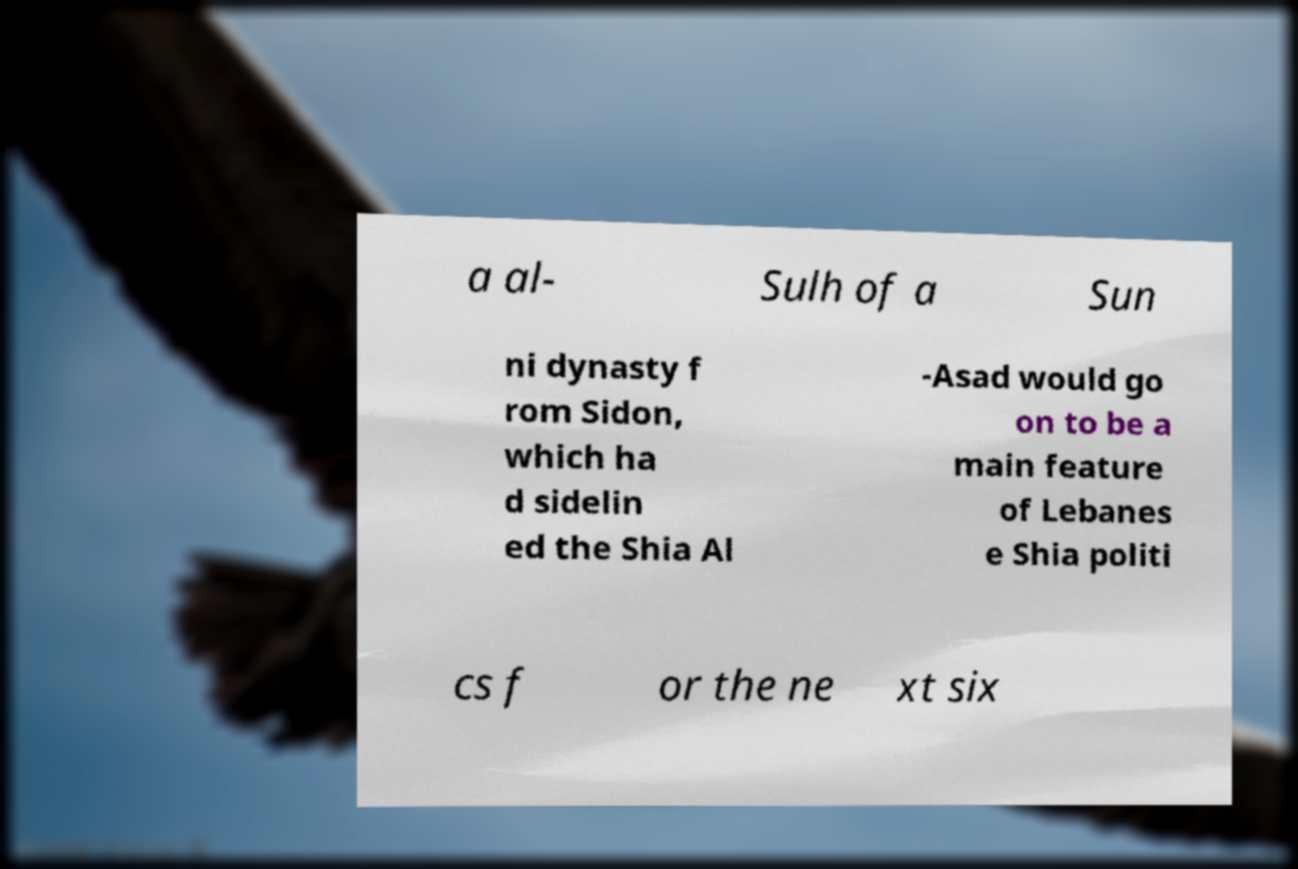Can you accurately transcribe the text from the provided image for me? a al- Sulh of a Sun ni dynasty f rom Sidon, which ha d sidelin ed the Shia Al -Asad would go on to be a main feature of Lebanes e Shia politi cs f or the ne xt six 